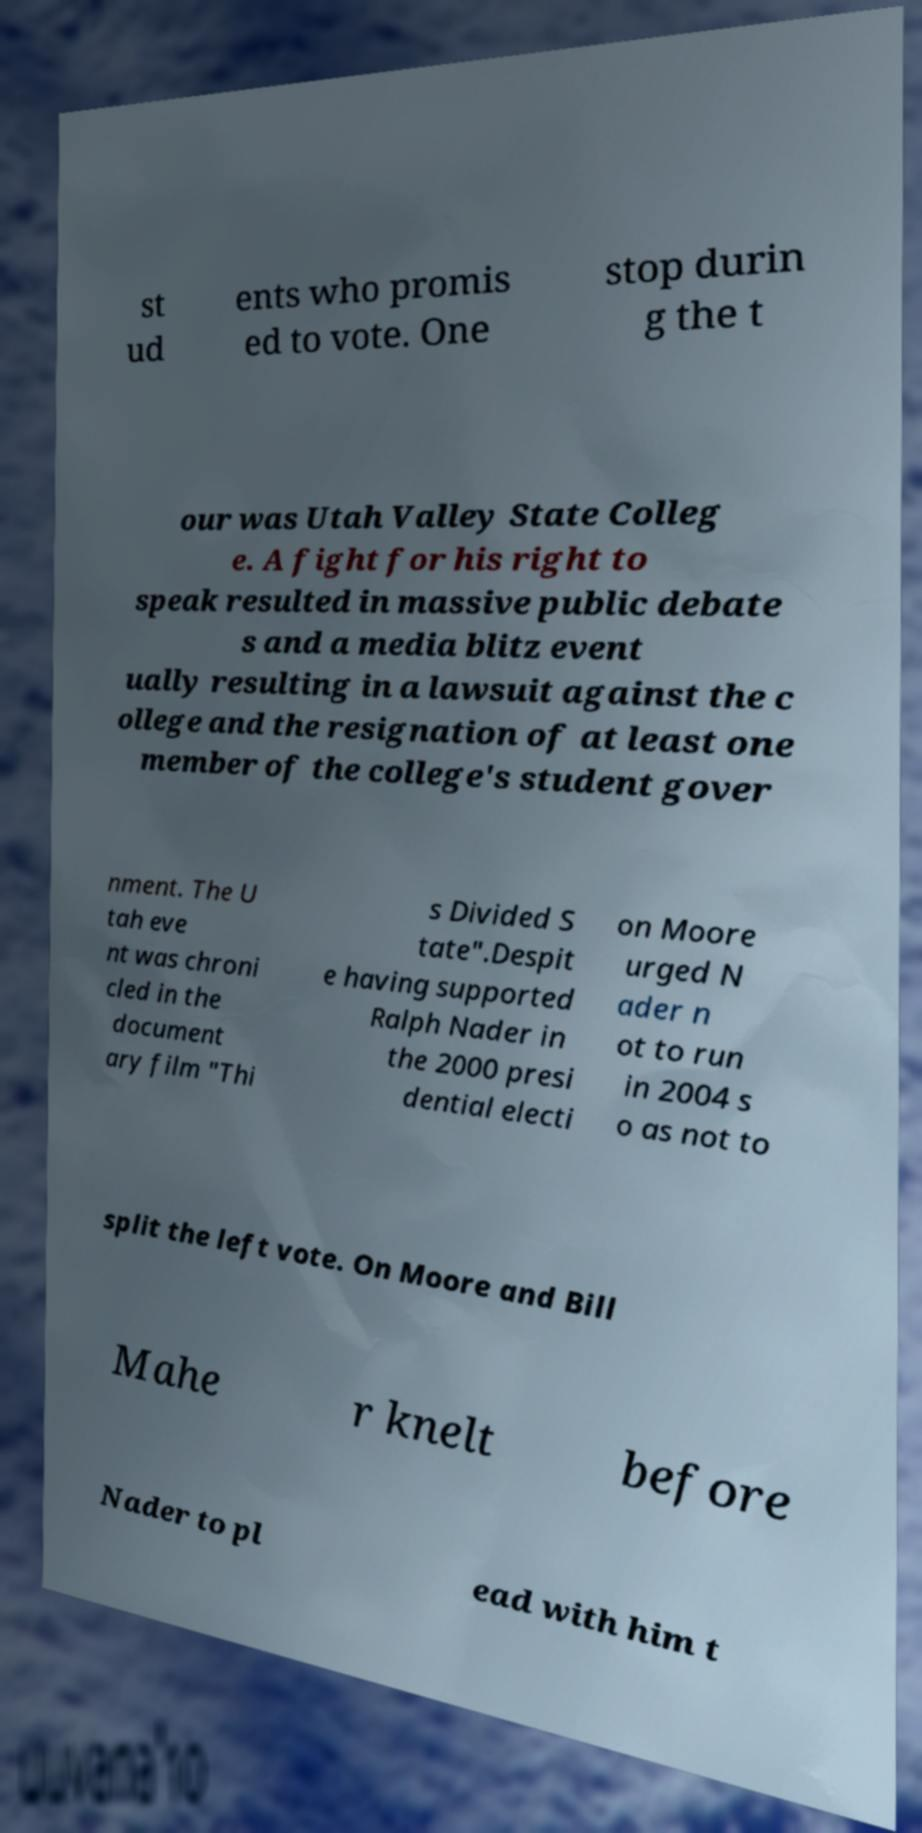Can you read and provide the text displayed in the image?This photo seems to have some interesting text. Can you extract and type it out for me? st ud ents who promis ed to vote. One stop durin g the t our was Utah Valley State Colleg e. A fight for his right to speak resulted in massive public debate s and a media blitz event ually resulting in a lawsuit against the c ollege and the resignation of at least one member of the college's student gover nment. The U tah eve nt was chroni cled in the document ary film "Thi s Divided S tate".Despit e having supported Ralph Nader in the 2000 presi dential electi on Moore urged N ader n ot to run in 2004 s o as not to split the left vote. On Moore and Bill Mahe r knelt before Nader to pl ead with him t 